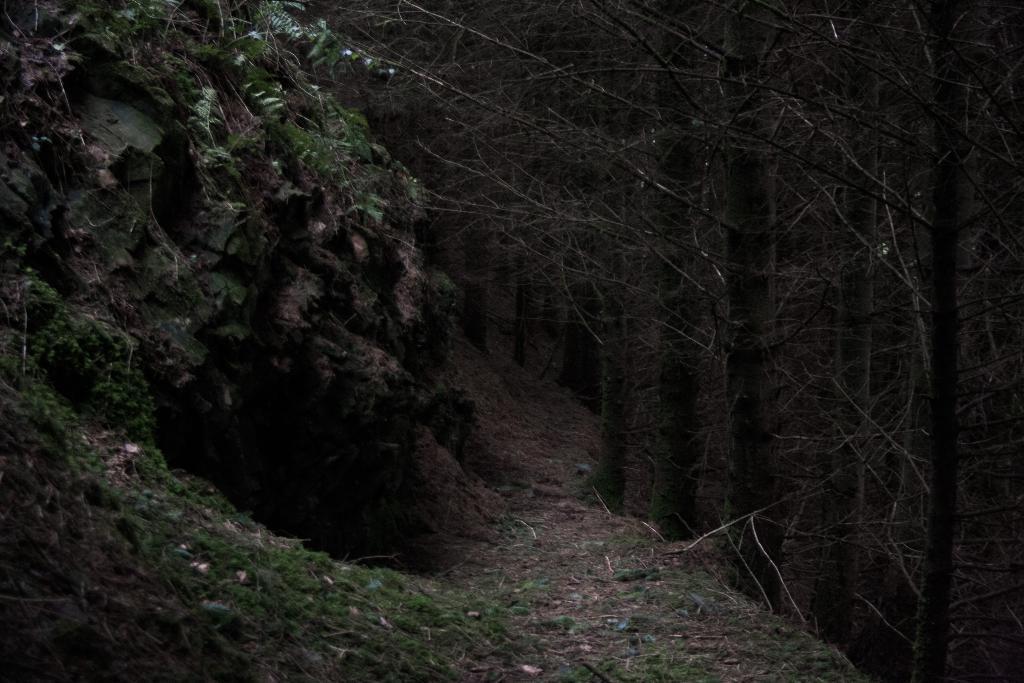How would you summarize this image in a sentence or two? In the picture we can see a rock slope with plants and beside it, we can see the trees. 